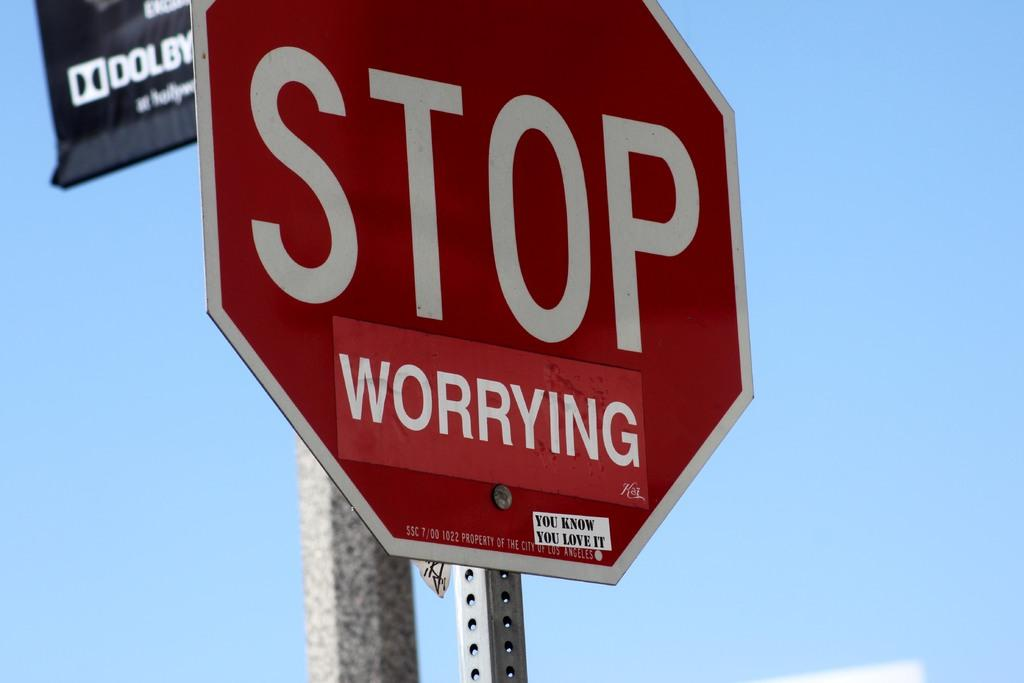<image>
Give a short and clear explanation of the subsequent image. Due to a sticker being added to the sign, it now reads STOP worrying. 